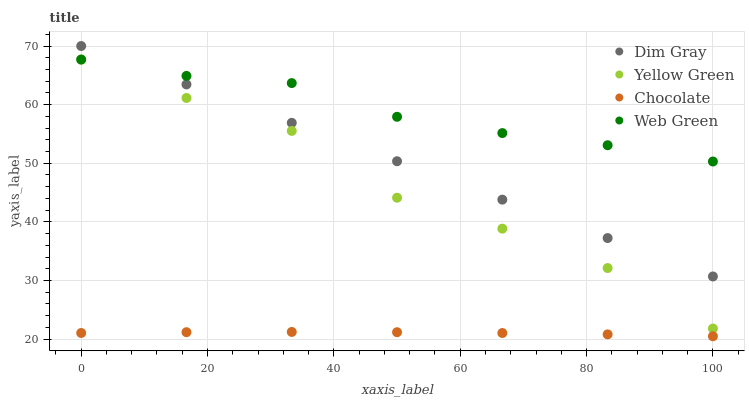Does Chocolate have the minimum area under the curve?
Answer yes or no. Yes. Does Web Green have the maximum area under the curve?
Answer yes or no. Yes. Does Yellow Green have the minimum area under the curve?
Answer yes or no. No. Does Yellow Green have the maximum area under the curve?
Answer yes or no. No. Is Dim Gray the smoothest?
Answer yes or no. Yes. Is Yellow Green the roughest?
Answer yes or no. Yes. Is Web Green the smoothest?
Answer yes or no. No. Is Web Green the roughest?
Answer yes or no. No. Does Chocolate have the lowest value?
Answer yes or no. Yes. Does Yellow Green have the lowest value?
Answer yes or no. No. Does Dim Gray have the highest value?
Answer yes or no. Yes. Does Yellow Green have the highest value?
Answer yes or no. No. Is Chocolate less than Yellow Green?
Answer yes or no. Yes. Is Yellow Green greater than Chocolate?
Answer yes or no. Yes. Does Dim Gray intersect Web Green?
Answer yes or no. Yes. Is Dim Gray less than Web Green?
Answer yes or no. No. Is Dim Gray greater than Web Green?
Answer yes or no. No. Does Chocolate intersect Yellow Green?
Answer yes or no. No. 